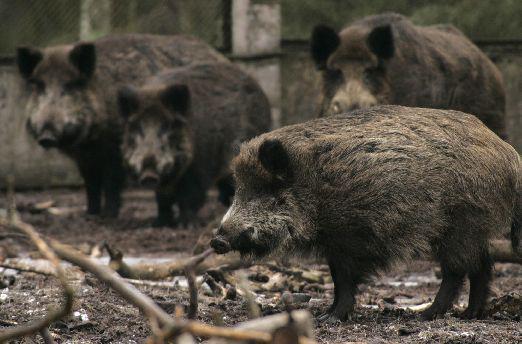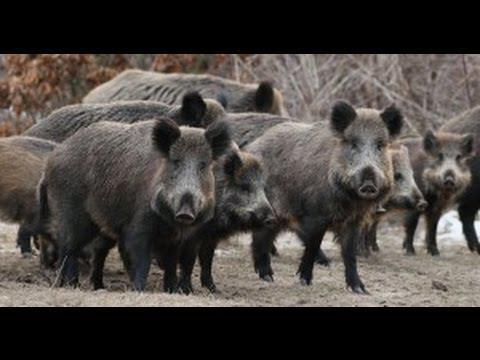The first image is the image on the left, the second image is the image on the right. Assess this claim about the two images: "Each image shows exactly one wild boar.". Correct or not? Answer yes or no. No. The first image is the image on the left, the second image is the image on the right. Analyze the images presented: Is the assertion "A single wild pig stands in the grass in the image on the left." valid? Answer yes or no. No. 